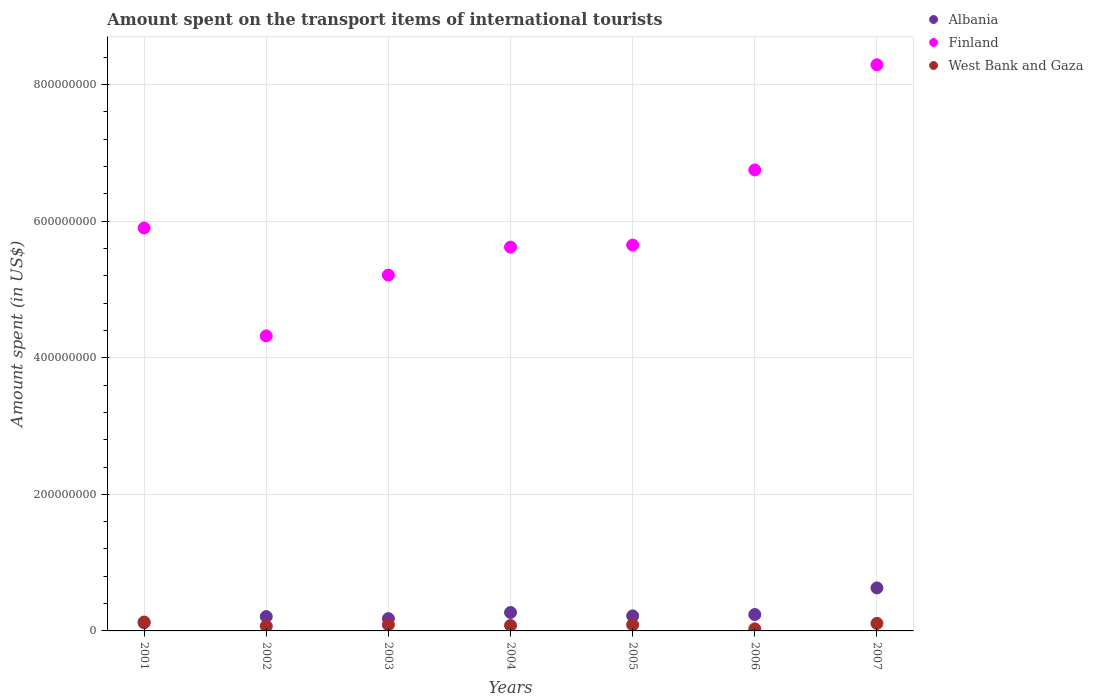How many different coloured dotlines are there?
Give a very brief answer. 3. Is the number of dotlines equal to the number of legend labels?
Your response must be concise. Yes. What is the amount spent on the transport items of international tourists in Albania in 2003?
Keep it short and to the point. 1.80e+07. Across all years, what is the maximum amount spent on the transport items of international tourists in West Bank and Gaza?
Offer a very short reply. 1.30e+07. Across all years, what is the minimum amount spent on the transport items of international tourists in West Bank and Gaza?
Ensure brevity in your answer.  3.00e+06. In which year was the amount spent on the transport items of international tourists in West Bank and Gaza maximum?
Make the answer very short. 2001. What is the total amount spent on the transport items of international tourists in West Bank and Gaza in the graph?
Provide a short and direct response. 6.00e+07. What is the difference between the amount spent on the transport items of international tourists in Finland in 2003 and that in 2006?
Provide a short and direct response. -1.54e+08. What is the difference between the amount spent on the transport items of international tourists in Albania in 2005 and the amount spent on the transport items of international tourists in West Bank and Gaza in 2007?
Your response must be concise. 1.10e+07. What is the average amount spent on the transport items of international tourists in Albania per year?
Provide a succinct answer. 2.67e+07. In the year 2002, what is the difference between the amount spent on the transport items of international tourists in Albania and amount spent on the transport items of international tourists in West Bank and Gaza?
Your answer should be compact. 1.40e+07. What is the ratio of the amount spent on the transport items of international tourists in Albania in 2001 to that in 2004?
Ensure brevity in your answer.  0.44. Is the amount spent on the transport items of international tourists in Albania in 2002 less than that in 2004?
Offer a terse response. Yes. What is the difference between the highest and the lowest amount spent on the transport items of international tourists in Finland?
Keep it short and to the point. 3.97e+08. In how many years, is the amount spent on the transport items of international tourists in West Bank and Gaza greater than the average amount spent on the transport items of international tourists in West Bank and Gaza taken over all years?
Your answer should be very brief. 4. Is it the case that in every year, the sum of the amount spent on the transport items of international tourists in Finland and amount spent on the transport items of international tourists in Albania  is greater than the amount spent on the transport items of international tourists in West Bank and Gaza?
Ensure brevity in your answer.  Yes. Does the amount spent on the transport items of international tourists in Finland monotonically increase over the years?
Ensure brevity in your answer.  No. How many dotlines are there?
Offer a terse response. 3. Does the graph contain grids?
Offer a terse response. Yes. How are the legend labels stacked?
Ensure brevity in your answer.  Vertical. What is the title of the graph?
Offer a very short reply. Amount spent on the transport items of international tourists. Does "Monaco" appear as one of the legend labels in the graph?
Give a very brief answer. No. What is the label or title of the Y-axis?
Provide a succinct answer. Amount spent (in US$). What is the Amount spent (in US$) in Finland in 2001?
Your answer should be very brief. 5.90e+08. What is the Amount spent (in US$) of West Bank and Gaza in 2001?
Give a very brief answer. 1.30e+07. What is the Amount spent (in US$) of Albania in 2002?
Offer a very short reply. 2.10e+07. What is the Amount spent (in US$) of Finland in 2002?
Offer a terse response. 4.32e+08. What is the Amount spent (in US$) in Albania in 2003?
Make the answer very short. 1.80e+07. What is the Amount spent (in US$) of Finland in 2003?
Ensure brevity in your answer.  5.21e+08. What is the Amount spent (in US$) of West Bank and Gaza in 2003?
Your response must be concise. 9.00e+06. What is the Amount spent (in US$) in Albania in 2004?
Provide a short and direct response. 2.70e+07. What is the Amount spent (in US$) of Finland in 2004?
Ensure brevity in your answer.  5.62e+08. What is the Amount spent (in US$) of West Bank and Gaza in 2004?
Provide a short and direct response. 8.00e+06. What is the Amount spent (in US$) of Albania in 2005?
Keep it short and to the point. 2.20e+07. What is the Amount spent (in US$) in Finland in 2005?
Provide a short and direct response. 5.65e+08. What is the Amount spent (in US$) of West Bank and Gaza in 2005?
Offer a very short reply. 9.00e+06. What is the Amount spent (in US$) of Albania in 2006?
Offer a very short reply. 2.40e+07. What is the Amount spent (in US$) in Finland in 2006?
Provide a succinct answer. 6.75e+08. What is the Amount spent (in US$) of Albania in 2007?
Your response must be concise. 6.30e+07. What is the Amount spent (in US$) of Finland in 2007?
Provide a succinct answer. 8.29e+08. What is the Amount spent (in US$) in West Bank and Gaza in 2007?
Provide a short and direct response. 1.10e+07. Across all years, what is the maximum Amount spent (in US$) in Albania?
Make the answer very short. 6.30e+07. Across all years, what is the maximum Amount spent (in US$) of Finland?
Offer a terse response. 8.29e+08. Across all years, what is the maximum Amount spent (in US$) of West Bank and Gaza?
Your answer should be compact. 1.30e+07. Across all years, what is the minimum Amount spent (in US$) in Finland?
Keep it short and to the point. 4.32e+08. Across all years, what is the minimum Amount spent (in US$) in West Bank and Gaza?
Offer a terse response. 3.00e+06. What is the total Amount spent (in US$) of Albania in the graph?
Keep it short and to the point. 1.87e+08. What is the total Amount spent (in US$) in Finland in the graph?
Make the answer very short. 4.17e+09. What is the total Amount spent (in US$) in West Bank and Gaza in the graph?
Provide a short and direct response. 6.00e+07. What is the difference between the Amount spent (in US$) in Albania in 2001 and that in 2002?
Ensure brevity in your answer.  -9.00e+06. What is the difference between the Amount spent (in US$) in Finland in 2001 and that in 2002?
Make the answer very short. 1.58e+08. What is the difference between the Amount spent (in US$) in Albania in 2001 and that in 2003?
Make the answer very short. -6.00e+06. What is the difference between the Amount spent (in US$) of Finland in 2001 and that in 2003?
Ensure brevity in your answer.  6.90e+07. What is the difference between the Amount spent (in US$) in Albania in 2001 and that in 2004?
Offer a terse response. -1.50e+07. What is the difference between the Amount spent (in US$) in Finland in 2001 and that in 2004?
Your response must be concise. 2.80e+07. What is the difference between the Amount spent (in US$) in Albania in 2001 and that in 2005?
Your answer should be very brief. -1.00e+07. What is the difference between the Amount spent (in US$) of Finland in 2001 and that in 2005?
Offer a terse response. 2.50e+07. What is the difference between the Amount spent (in US$) in West Bank and Gaza in 2001 and that in 2005?
Offer a terse response. 4.00e+06. What is the difference between the Amount spent (in US$) of Albania in 2001 and that in 2006?
Your answer should be very brief. -1.20e+07. What is the difference between the Amount spent (in US$) of Finland in 2001 and that in 2006?
Your answer should be very brief. -8.50e+07. What is the difference between the Amount spent (in US$) in Albania in 2001 and that in 2007?
Give a very brief answer. -5.10e+07. What is the difference between the Amount spent (in US$) of Finland in 2001 and that in 2007?
Provide a succinct answer. -2.39e+08. What is the difference between the Amount spent (in US$) of Finland in 2002 and that in 2003?
Provide a succinct answer. -8.90e+07. What is the difference between the Amount spent (in US$) in Albania in 2002 and that in 2004?
Offer a terse response. -6.00e+06. What is the difference between the Amount spent (in US$) in Finland in 2002 and that in 2004?
Give a very brief answer. -1.30e+08. What is the difference between the Amount spent (in US$) of West Bank and Gaza in 2002 and that in 2004?
Provide a succinct answer. -1.00e+06. What is the difference between the Amount spent (in US$) of Albania in 2002 and that in 2005?
Your answer should be compact. -1.00e+06. What is the difference between the Amount spent (in US$) of Finland in 2002 and that in 2005?
Offer a very short reply. -1.33e+08. What is the difference between the Amount spent (in US$) of Albania in 2002 and that in 2006?
Ensure brevity in your answer.  -3.00e+06. What is the difference between the Amount spent (in US$) in Finland in 2002 and that in 2006?
Your answer should be compact. -2.43e+08. What is the difference between the Amount spent (in US$) of Albania in 2002 and that in 2007?
Provide a succinct answer. -4.20e+07. What is the difference between the Amount spent (in US$) of Finland in 2002 and that in 2007?
Your answer should be very brief. -3.97e+08. What is the difference between the Amount spent (in US$) in Albania in 2003 and that in 2004?
Keep it short and to the point. -9.00e+06. What is the difference between the Amount spent (in US$) of Finland in 2003 and that in 2004?
Provide a short and direct response. -4.10e+07. What is the difference between the Amount spent (in US$) in Finland in 2003 and that in 2005?
Ensure brevity in your answer.  -4.40e+07. What is the difference between the Amount spent (in US$) of West Bank and Gaza in 2003 and that in 2005?
Provide a succinct answer. 0. What is the difference between the Amount spent (in US$) in Albania in 2003 and that in 2006?
Offer a very short reply. -6.00e+06. What is the difference between the Amount spent (in US$) in Finland in 2003 and that in 2006?
Your answer should be very brief. -1.54e+08. What is the difference between the Amount spent (in US$) in Albania in 2003 and that in 2007?
Give a very brief answer. -4.50e+07. What is the difference between the Amount spent (in US$) of Finland in 2003 and that in 2007?
Keep it short and to the point. -3.08e+08. What is the difference between the Amount spent (in US$) in Albania in 2004 and that in 2005?
Your answer should be compact. 5.00e+06. What is the difference between the Amount spent (in US$) in Finland in 2004 and that in 2005?
Offer a very short reply. -3.00e+06. What is the difference between the Amount spent (in US$) in Finland in 2004 and that in 2006?
Make the answer very short. -1.13e+08. What is the difference between the Amount spent (in US$) in Albania in 2004 and that in 2007?
Offer a very short reply. -3.60e+07. What is the difference between the Amount spent (in US$) in Finland in 2004 and that in 2007?
Your answer should be compact. -2.67e+08. What is the difference between the Amount spent (in US$) of Finland in 2005 and that in 2006?
Offer a very short reply. -1.10e+08. What is the difference between the Amount spent (in US$) in Albania in 2005 and that in 2007?
Give a very brief answer. -4.10e+07. What is the difference between the Amount spent (in US$) in Finland in 2005 and that in 2007?
Provide a short and direct response. -2.64e+08. What is the difference between the Amount spent (in US$) in West Bank and Gaza in 2005 and that in 2007?
Your response must be concise. -2.00e+06. What is the difference between the Amount spent (in US$) in Albania in 2006 and that in 2007?
Give a very brief answer. -3.90e+07. What is the difference between the Amount spent (in US$) of Finland in 2006 and that in 2007?
Provide a short and direct response. -1.54e+08. What is the difference between the Amount spent (in US$) of West Bank and Gaza in 2006 and that in 2007?
Your answer should be very brief. -8.00e+06. What is the difference between the Amount spent (in US$) in Albania in 2001 and the Amount spent (in US$) in Finland in 2002?
Provide a short and direct response. -4.20e+08. What is the difference between the Amount spent (in US$) in Finland in 2001 and the Amount spent (in US$) in West Bank and Gaza in 2002?
Your response must be concise. 5.83e+08. What is the difference between the Amount spent (in US$) of Albania in 2001 and the Amount spent (in US$) of Finland in 2003?
Provide a succinct answer. -5.09e+08. What is the difference between the Amount spent (in US$) in Albania in 2001 and the Amount spent (in US$) in West Bank and Gaza in 2003?
Provide a short and direct response. 3.00e+06. What is the difference between the Amount spent (in US$) of Finland in 2001 and the Amount spent (in US$) of West Bank and Gaza in 2003?
Offer a very short reply. 5.81e+08. What is the difference between the Amount spent (in US$) of Albania in 2001 and the Amount spent (in US$) of Finland in 2004?
Your response must be concise. -5.50e+08. What is the difference between the Amount spent (in US$) of Albania in 2001 and the Amount spent (in US$) of West Bank and Gaza in 2004?
Give a very brief answer. 4.00e+06. What is the difference between the Amount spent (in US$) in Finland in 2001 and the Amount spent (in US$) in West Bank and Gaza in 2004?
Your answer should be very brief. 5.82e+08. What is the difference between the Amount spent (in US$) in Albania in 2001 and the Amount spent (in US$) in Finland in 2005?
Your response must be concise. -5.53e+08. What is the difference between the Amount spent (in US$) in Finland in 2001 and the Amount spent (in US$) in West Bank and Gaza in 2005?
Your response must be concise. 5.81e+08. What is the difference between the Amount spent (in US$) in Albania in 2001 and the Amount spent (in US$) in Finland in 2006?
Offer a very short reply. -6.63e+08. What is the difference between the Amount spent (in US$) of Albania in 2001 and the Amount spent (in US$) of West Bank and Gaza in 2006?
Offer a terse response. 9.00e+06. What is the difference between the Amount spent (in US$) in Finland in 2001 and the Amount spent (in US$) in West Bank and Gaza in 2006?
Ensure brevity in your answer.  5.87e+08. What is the difference between the Amount spent (in US$) of Albania in 2001 and the Amount spent (in US$) of Finland in 2007?
Your response must be concise. -8.17e+08. What is the difference between the Amount spent (in US$) of Finland in 2001 and the Amount spent (in US$) of West Bank and Gaza in 2007?
Provide a succinct answer. 5.79e+08. What is the difference between the Amount spent (in US$) in Albania in 2002 and the Amount spent (in US$) in Finland in 2003?
Your answer should be very brief. -5.00e+08. What is the difference between the Amount spent (in US$) in Albania in 2002 and the Amount spent (in US$) in West Bank and Gaza in 2003?
Ensure brevity in your answer.  1.20e+07. What is the difference between the Amount spent (in US$) in Finland in 2002 and the Amount spent (in US$) in West Bank and Gaza in 2003?
Your answer should be compact. 4.23e+08. What is the difference between the Amount spent (in US$) of Albania in 2002 and the Amount spent (in US$) of Finland in 2004?
Keep it short and to the point. -5.41e+08. What is the difference between the Amount spent (in US$) of Albania in 2002 and the Amount spent (in US$) of West Bank and Gaza in 2004?
Provide a succinct answer. 1.30e+07. What is the difference between the Amount spent (in US$) in Finland in 2002 and the Amount spent (in US$) in West Bank and Gaza in 2004?
Your response must be concise. 4.24e+08. What is the difference between the Amount spent (in US$) in Albania in 2002 and the Amount spent (in US$) in Finland in 2005?
Provide a short and direct response. -5.44e+08. What is the difference between the Amount spent (in US$) in Albania in 2002 and the Amount spent (in US$) in West Bank and Gaza in 2005?
Make the answer very short. 1.20e+07. What is the difference between the Amount spent (in US$) in Finland in 2002 and the Amount spent (in US$) in West Bank and Gaza in 2005?
Offer a very short reply. 4.23e+08. What is the difference between the Amount spent (in US$) in Albania in 2002 and the Amount spent (in US$) in Finland in 2006?
Offer a very short reply. -6.54e+08. What is the difference between the Amount spent (in US$) of Albania in 2002 and the Amount spent (in US$) of West Bank and Gaza in 2006?
Give a very brief answer. 1.80e+07. What is the difference between the Amount spent (in US$) in Finland in 2002 and the Amount spent (in US$) in West Bank and Gaza in 2006?
Ensure brevity in your answer.  4.29e+08. What is the difference between the Amount spent (in US$) of Albania in 2002 and the Amount spent (in US$) of Finland in 2007?
Provide a succinct answer. -8.08e+08. What is the difference between the Amount spent (in US$) in Finland in 2002 and the Amount spent (in US$) in West Bank and Gaza in 2007?
Offer a very short reply. 4.21e+08. What is the difference between the Amount spent (in US$) in Albania in 2003 and the Amount spent (in US$) in Finland in 2004?
Provide a short and direct response. -5.44e+08. What is the difference between the Amount spent (in US$) in Finland in 2003 and the Amount spent (in US$) in West Bank and Gaza in 2004?
Provide a succinct answer. 5.13e+08. What is the difference between the Amount spent (in US$) of Albania in 2003 and the Amount spent (in US$) of Finland in 2005?
Give a very brief answer. -5.47e+08. What is the difference between the Amount spent (in US$) in Albania in 2003 and the Amount spent (in US$) in West Bank and Gaza in 2005?
Keep it short and to the point. 9.00e+06. What is the difference between the Amount spent (in US$) of Finland in 2003 and the Amount spent (in US$) of West Bank and Gaza in 2005?
Provide a short and direct response. 5.12e+08. What is the difference between the Amount spent (in US$) of Albania in 2003 and the Amount spent (in US$) of Finland in 2006?
Offer a terse response. -6.57e+08. What is the difference between the Amount spent (in US$) in Albania in 2003 and the Amount spent (in US$) in West Bank and Gaza in 2006?
Provide a succinct answer. 1.50e+07. What is the difference between the Amount spent (in US$) in Finland in 2003 and the Amount spent (in US$) in West Bank and Gaza in 2006?
Your answer should be very brief. 5.18e+08. What is the difference between the Amount spent (in US$) of Albania in 2003 and the Amount spent (in US$) of Finland in 2007?
Make the answer very short. -8.11e+08. What is the difference between the Amount spent (in US$) of Finland in 2003 and the Amount spent (in US$) of West Bank and Gaza in 2007?
Offer a terse response. 5.10e+08. What is the difference between the Amount spent (in US$) in Albania in 2004 and the Amount spent (in US$) in Finland in 2005?
Your response must be concise. -5.38e+08. What is the difference between the Amount spent (in US$) in Albania in 2004 and the Amount spent (in US$) in West Bank and Gaza in 2005?
Provide a short and direct response. 1.80e+07. What is the difference between the Amount spent (in US$) in Finland in 2004 and the Amount spent (in US$) in West Bank and Gaza in 2005?
Provide a succinct answer. 5.53e+08. What is the difference between the Amount spent (in US$) in Albania in 2004 and the Amount spent (in US$) in Finland in 2006?
Offer a terse response. -6.48e+08. What is the difference between the Amount spent (in US$) in Albania in 2004 and the Amount spent (in US$) in West Bank and Gaza in 2006?
Your answer should be very brief. 2.40e+07. What is the difference between the Amount spent (in US$) of Finland in 2004 and the Amount spent (in US$) of West Bank and Gaza in 2006?
Provide a succinct answer. 5.59e+08. What is the difference between the Amount spent (in US$) of Albania in 2004 and the Amount spent (in US$) of Finland in 2007?
Offer a very short reply. -8.02e+08. What is the difference between the Amount spent (in US$) in Albania in 2004 and the Amount spent (in US$) in West Bank and Gaza in 2007?
Provide a short and direct response. 1.60e+07. What is the difference between the Amount spent (in US$) of Finland in 2004 and the Amount spent (in US$) of West Bank and Gaza in 2007?
Make the answer very short. 5.51e+08. What is the difference between the Amount spent (in US$) of Albania in 2005 and the Amount spent (in US$) of Finland in 2006?
Provide a succinct answer. -6.53e+08. What is the difference between the Amount spent (in US$) in Albania in 2005 and the Amount spent (in US$) in West Bank and Gaza in 2006?
Your answer should be compact. 1.90e+07. What is the difference between the Amount spent (in US$) of Finland in 2005 and the Amount spent (in US$) of West Bank and Gaza in 2006?
Your answer should be compact. 5.62e+08. What is the difference between the Amount spent (in US$) in Albania in 2005 and the Amount spent (in US$) in Finland in 2007?
Your response must be concise. -8.07e+08. What is the difference between the Amount spent (in US$) in Albania in 2005 and the Amount spent (in US$) in West Bank and Gaza in 2007?
Your response must be concise. 1.10e+07. What is the difference between the Amount spent (in US$) of Finland in 2005 and the Amount spent (in US$) of West Bank and Gaza in 2007?
Give a very brief answer. 5.54e+08. What is the difference between the Amount spent (in US$) in Albania in 2006 and the Amount spent (in US$) in Finland in 2007?
Give a very brief answer. -8.05e+08. What is the difference between the Amount spent (in US$) of Albania in 2006 and the Amount spent (in US$) of West Bank and Gaza in 2007?
Provide a succinct answer. 1.30e+07. What is the difference between the Amount spent (in US$) of Finland in 2006 and the Amount spent (in US$) of West Bank and Gaza in 2007?
Your answer should be compact. 6.64e+08. What is the average Amount spent (in US$) of Albania per year?
Give a very brief answer. 2.67e+07. What is the average Amount spent (in US$) in Finland per year?
Offer a terse response. 5.96e+08. What is the average Amount spent (in US$) of West Bank and Gaza per year?
Your response must be concise. 8.57e+06. In the year 2001, what is the difference between the Amount spent (in US$) of Albania and Amount spent (in US$) of Finland?
Your answer should be compact. -5.78e+08. In the year 2001, what is the difference between the Amount spent (in US$) of Albania and Amount spent (in US$) of West Bank and Gaza?
Your response must be concise. -1.00e+06. In the year 2001, what is the difference between the Amount spent (in US$) of Finland and Amount spent (in US$) of West Bank and Gaza?
Your answer should be compact. 5.77e+08. In the year 2002, what is the difference between the Amount spent (in US$) in Albania and Amount spent (in US$) in Finland?
Make the answer very short. -4.11e+08. In the year 2002, what is the difference between the Amount spent (in US$) in Albania and Amount spent (in US$) in West Bank and Gaza?
Keep it short and to the point. 1.40e+07. In the year 2002, what is the difference between the Amount spent (in US$) of Finland and Amount spent (in US$) of West Bank and Gaza?
Provide a succinct answer. 4.25e+08. In the year 2003, what is the difference between the Amount spent (in US$) of Albania and Amount spent (in US$) of Finland?
Your answer should be compact. -5.03e+08. In the year 2003, what is the difference between the Amount spent (in US$) in Albania and Amount spent (in US$) in West Bank and Gaza?
Make the answer very short. 9.00e+06. In the year 2003, what is the difference between the Amount spent (in US$) in Finland and Amount spent (in US$) in West Bank and Gaza?
Offer a terse response. 5.12e+08. In the year 2004, what is the difference between the Amount spent (in US$) of Albania and Amount spent (in US$) of Finland?
Your response must be concise. -5.35e+08. In the year 2004, what is the difference between the Amount spent (in US$) of Albania and Amount spent (in US$) of West Bank and Gaza?
Your response must be concise. 1.90e+07. In the year 2004, what is the difference between the Amount spent (in US$) in Finland and Amount spent (in US$) in West Bank and Gaza?
Keep it short and to the point. 5.54e+08. In the year 2005, what is the difference between the Amount spent (in US$) in Albania and Amount spent (in US$) in Finland?
Provide a succinct answer. -5.43e+08. In the year 2005, what is the difference between the Amount spent (in US$) of Albania and Amount spent (in US$) of West Bank and Gaza?
Provide a short and direct response. 1.30e+07. In the year 2005, what is the difference between the Amount spent (in US$) in Finland and Amount spent (in US$) in West Bank and Gaza?
Make the answer very short. 5.56e+08. In the year 2006, what is the difference between the Amount spent (in US$) in Albania and Amount spent (in US$) in Finland?
Your answer should be very brief. -6.51e+08. In the year 2006, what is the difference between the Amount spent (in US$) of Albania and Amount spent (in US$) of West Bank and Gaza?
Provide a short and direct response. 2.10e+07. In the year 2006, what is the difference between the Amount spent (in US$) in Finland and Amount spent (in US$) in West Bank and Gaza?
Your answer should be very brief. 6.72e+08. In the year 2007, what is the difference between the Amount spent (in US$) in Albania and Amount spent (in US$) in Finland?
Offer a very short reply. -7.66e+08. In the year 2007, what is the difference between the Amount spent (in US$) of Albania and Amount spent (in US$) of West Bank and Gaza?
Provide a succinct answer. 5.20e+07. In the year 2007, what is the difference between the Amount spent (in US$) in Finland and Amount spent (in US$) in West Bank and Gaza?
Ensure brevity in your answer.  8.18e+08. What is the ratio of the Amount spent (in US$) in Finland in 2001 to that in 2002?
Provide a succinct answer. 1.37. What is the ratio of the Amount spent (in US$) in West Bank and Gaza in 2001 to that in 2002?
Offer a terse response. 1.86. What is the ratio of the Amount spent (in US$) of Finland in 2001 to that in 2003?
Keep it short and to the point. 1.13. What is the ratio of the Amount spent (in US$) of West Bank and Gaza in 2001 to that in 2003?
Your response must be concise. 1.44. What is the ratio of the Amount spent (in US$) in Albania in 2001 to that in 2004?
Give a very brief answer. 0.44. What is the ratio of the Amount spent (in US$) of Finland in 2001 to that in 2004?
Make the answer very short. 1.05. What is the ratio of the Amount spent (in US$) in West Bank and Gaza in 2001 to that in 2004?
Give a very brief answer. 1.62. What is the ratio of the Amount spent (in US$) in Albania in 2001 to that in 2005?
Keep it short and to the point. 0.55. What is the ratio of the Amount spent (in US$) of Finland in 2001 to that in 2005?
Provide a succinct answer. 1.04. What is the ratio of the Amount spent (in US$) of West Bank and Gaza in 2001 to that in 2005?
Give a very brief answer. 1.44. What is the ratio of the Amount spent (in US$) of Finland in 2001 to that in 2006?
Provide a short and direct response. 0.87. What is the ratio of the Amount spent (in US$) of West Bank and Gaza in 2001 to that in 2006?
Offer a terse response. 4.33. What is the ratio of the Amount spent (in US$) of Albania in 2001 to that in 2007?
Offer a very short reply. 0.19. What is the ratio of the Amount spent (in US$) in Finland in 2001 to that in 2007?
Offer a very short reply. 0.71. What is the ratio of the Amount spent (in US$) of West Bank and Gaza in 2001 to that in 2007?
Offer a terse response. 1.18. What is the ratio of the Amount spent (in US$) of Finland in 2002 to that in 2003?
Provide a succinct answer. 0.83. What is the ratio of the Amount spent (in US$) in Albania in 2002 to that in 2004?
Give a very brief answer. 0.78. What is the ratio of the Amount spent (in US$) in Finland in 2002 to that in 2004?
Make the answer very short. 0.77. What is the ratio of the Amount spent (in US$) in Albania in 2002 to that in 2005?
Your response must be concise. 0.95. What is the ratio of the Amount spent (in US$) of Finland in 2002 to that in 2005?
Ensure brevity in your answer.  0.76. What is the ratio of the Amount spent (in US$) in West Bank and Gaza in 2002 to that in 2005?
Offer a terse response. 0.78. What is the ratio of the Amount spent (in US$) of Albania in 2002 to that in 2006?
Provide a short and direct response. 0.88. What is the ratio of the Amount spent (in US$) in Finland in 2002 to that in 2006?
Offer a terse response. 0.64. What is the ratio of the Amount spent (in US$) of West Bank and Gaza in 2002 to that in 2006?
Offer a very short reply. 2.33. What is the ratio of the Amount spent (in US$) of Albania in 2002 to that in 2007?
Ensure brevity in your answer.  0.33. What is the ratio of the Amount spent (in US$) in Finland in 2002 to that in 2007?
Give a very brief answer. 0.52. What is the ratio of the Amount spent (in US$) of West Bank and Gaza in 2002 to that in 2007?
Offer a very short reply. 0.64. What is the ratio of the Amount spent (in US$) in Albania in 2003 to that in 2004?
Your response must be concise. 0.67. What is the ratio of the Amount spent (in US$) of Finland in 2003 to that in 2004?
Your answer should be very brief. 0.93. What is the ratio of the Amount spent (in US$) of Albania in 2003 to that in 2005?
Provide a short and direct response. 0.82. What is the ratio of the Amount spent (in US$) of Finland in 2003 to that in 2005?
Keep it short and to the point. 0.92. What is the ratio of the Amount spent (in US$) of Finland in 2003 to that in 2006?
Make the answer very short. 0.77. What is the ratio of the Amount spent (in US$) of West Bank and Gaza in 2003 to that in 2006?
Offer a terse response. 3. What is the ratio of the Amount spent (in US$) in Albania in 2003 to that in 2007?
Provide a short and direct response. 0.29. What is the ratio of the Amount spent (in US$) in Finland in 2003 to that in 2007?
Your response must be concise. 0.63. What is the ratio of the Amount spent (in US$) of West Bank and Gaza in 2003 to that in 2007?
Give a very brief answer. 0.82. What is the ratio of the Amount spent (in US$) in Albania in 2004 to that in 2005?
Your answer should be very brief. 1.23. What is the ratio of the Amount spent (in US$) in Finland in 2004 to that in 2005?
Offer a very short reply. 0.99. What is the ratio of the Amount spent (in US$) of West Bank and Gaza in 2004 to that in 2005?
Ensure brevity in your answer.  0.89. What is the ratio of the Amount spent (in US$) in Albania in 2004 to that in 2006?
Your response must be concise. 1.12. What is the ratio of the Amount spent (in US$) in Finland in 2004 to that in 2006?
Provide a short and direct response. 0.83. What is the ratio of the Amount spent (in US$) of West Bank and Gaza in 2004 to that in 2006?
Offer a terse response. 2.67. What is the ratio of the Amount spent (in US$) of Albania in 2004 to that in 2007?
Give a very brief answer. 0.43. What is the ratio of the Amount spent (in US$) in Finland in 2004 to that in 2007?
Your answer should be very brief. 0.68. What is the ratio of the Amount spent (in US$) of West Bank and Gaza in 2004 to that in 2007?
Make the answer very short. 0.73. What is the ratio of the Amount spent (in US$) in Finland in 2005 to that in 2006?
Keep it short and to the point. 0.84. What is the ratio of the Amount spent (in US$) of West Bank and Gaza in 2005 to that in 2006?
Make the answer very short. 3. What is the ratio of the Amount spent (in US$) in Albania in 2005 to that in 2007?
Provide a succinct answer. 0.35. What is the ratio of the Amount spent (in US$) of Finland in 2005 to that in 2007?
Your response must be concise. 0.68. What is the ratio of the Amount spent (in US$) in West Bank and Gaza in 2005 to that in 2007?
Make the answer very short. 0.82. What is the ratio of the Amount spent (in US$) in Albania in 2006 to that in 2007?
Give a very brief answer. 0.38. What is the ratio of the Amount spent (in US$) in Finland in 2006 to that in 2007?
Your answer should be compact. 0.81. What is the ratio of the Amount spent (in US$) of West Bank and Gaza in 2006 to that in 2007?
Your answer should be compact. 0.27. What is the difference between the highest and the second highest Amount spent (in US$) of Albania?
Your response must be concise. 3.60e+07. What is the difference between the highest and the second highest Amount spent (in US$) in Finland?
Offer a terse response. 1.54e+08. What is the difference between the highest and the lowest Amount spent (in US$) in Albania?
Give a very brief answer. 5.10e+07. What is the difference between the highest and the lowest Amount spent (in US$) of Finland?
Ensure brevity in your answer.  3.97e+08. 